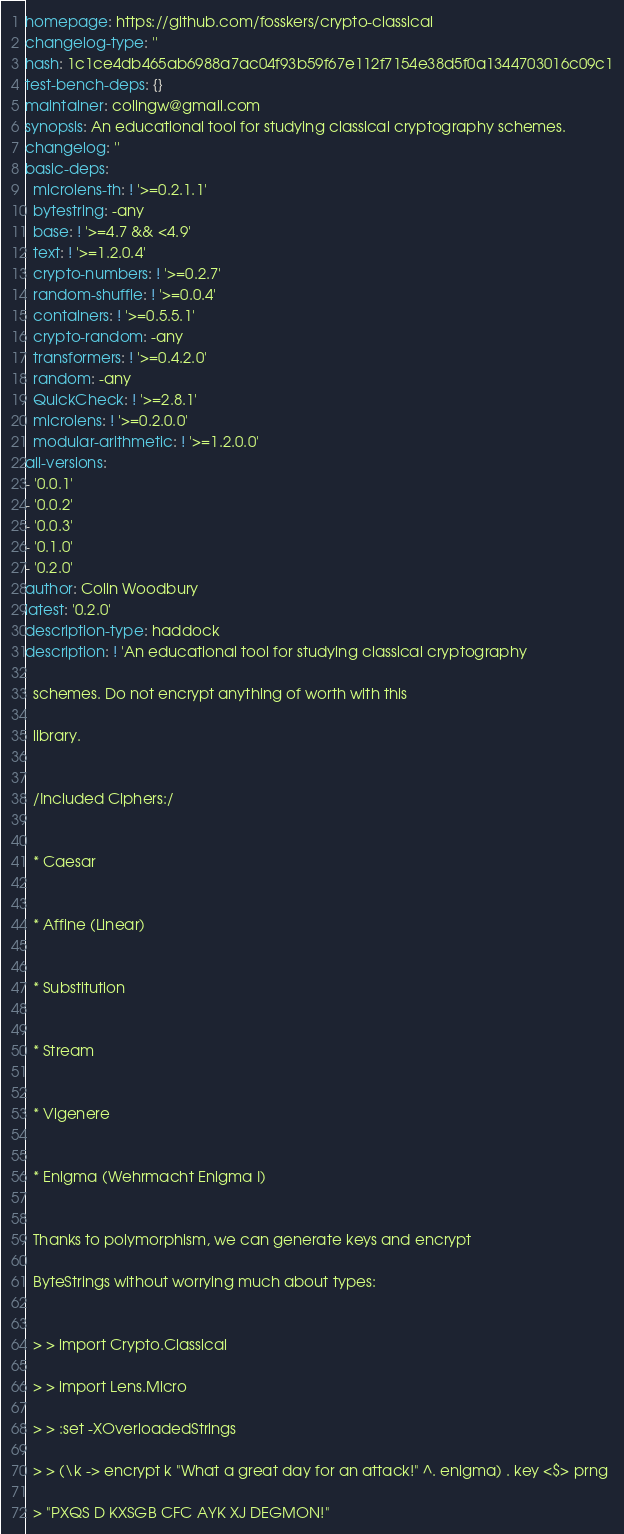<code> <loc_0><loc_0><loc_500><loc_500><_YAML_>homepage: https://github.com/fosskers/crypto-classical
changelog-type: ''
hash: 1c1ce4db465ab6988a7ac04f93b59f67e112f7154e38d5f0a1344703016c09c1
test-bench-deps: {}
maintainer: colingw@gmail.com
synopsis: An educational tool for studying classical cryptography schemes.
changelog: ''
basic-deps:
  microlens-th: ! '>=0.2.1.1'
  bytestring: -any
  base: ! '>=4.7 && <4.9'
  text: ! '>=1.2.0.4'
  crypto-numbers: ! '>=0.2.7'
  random-shuffle: ! '>=0.0.4'
  containers: ! '>=0.5.5.1'
  crypto-random: -any
  transformers: ! '>=0.4.2.0'
  random: -any
  QuickCheck: ! '>=2.8.1'
  microlens: ! '>=0.2.0.0'
  modular-arithmetic: ! '>=1.2.0.0'
all-versions:
- '0.0.1'
- '0.0.2'
- '0.0.3'
- '0.1.0'
- '0.2.0'
author: Colin Woodbury
latest: '0.2.0'
description-type: haddock
description: ! 'An educational tool for studying classical cryptography

  schemes. Do not encrypt anything of worth with this

  library.


  /Included Ciphers:/


  * Caesar


  * Affine (Linear)


  * Substitution


  * Stream


  * Vigenere


  * Enigma (Wehrmacht Enigma I)


  Thanks to polymorphism, we can generate keys and encrypt

  ByteStrings without worrying much about types:


  > > import Crypto.Classical

  > > import Lens.Micro

  > > :set -XOverloadedStrings

  > > (\k -> encrypt k "What a great day for an attack!" ^. enigma) . key <$> prng

  > "PXQS D KXSGB CFC AYK XJ DEGMON!"
</code> 